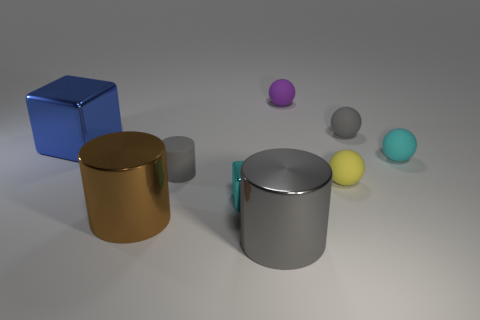There is a cyan block that is the same material as the big blue block; what size is it?
Provide a short and direct response. Small. What is the size of the gray rubber thing in front of the large thing behind the tiny matte thing on the left side of the purple sphere?
Make the answer very short. Small. Are there any big cylinders that have the same color as the small cylinder?
Ensure brevity in your answer.  Yes. Does the gray matte object that is on the left side of the cyan cube have the same size as the cyan matte thing?
Provide a succinct answer. Yes. Are there an equal number of blue things to the right of the small gray rubber sphere and tiny cyan cylinders?
Your answer should be very brief. Yes. How many things are large metal cylinders on the left side of the small metallic cube or tiny red shiny cylinders?
Keep it short and to the point. 1. What is the shape of the matte thing that is both on the left side of the yellow rubber sphere and in front of the purple sphere?
Provide a short and direct response. Cylinder. What number of things are rubber things on the right side of the tiny cyan metal cube or objects behind the tiny block?
Your answer should be very brief. 6. How many other things are there of the same size as the rubber cylinder?
Offer a terse response. 5. Does the large metal thing in front of the brown cylinder have the same color as the tiny rubber cylinder?
Provide a succinct answer. Yes. 